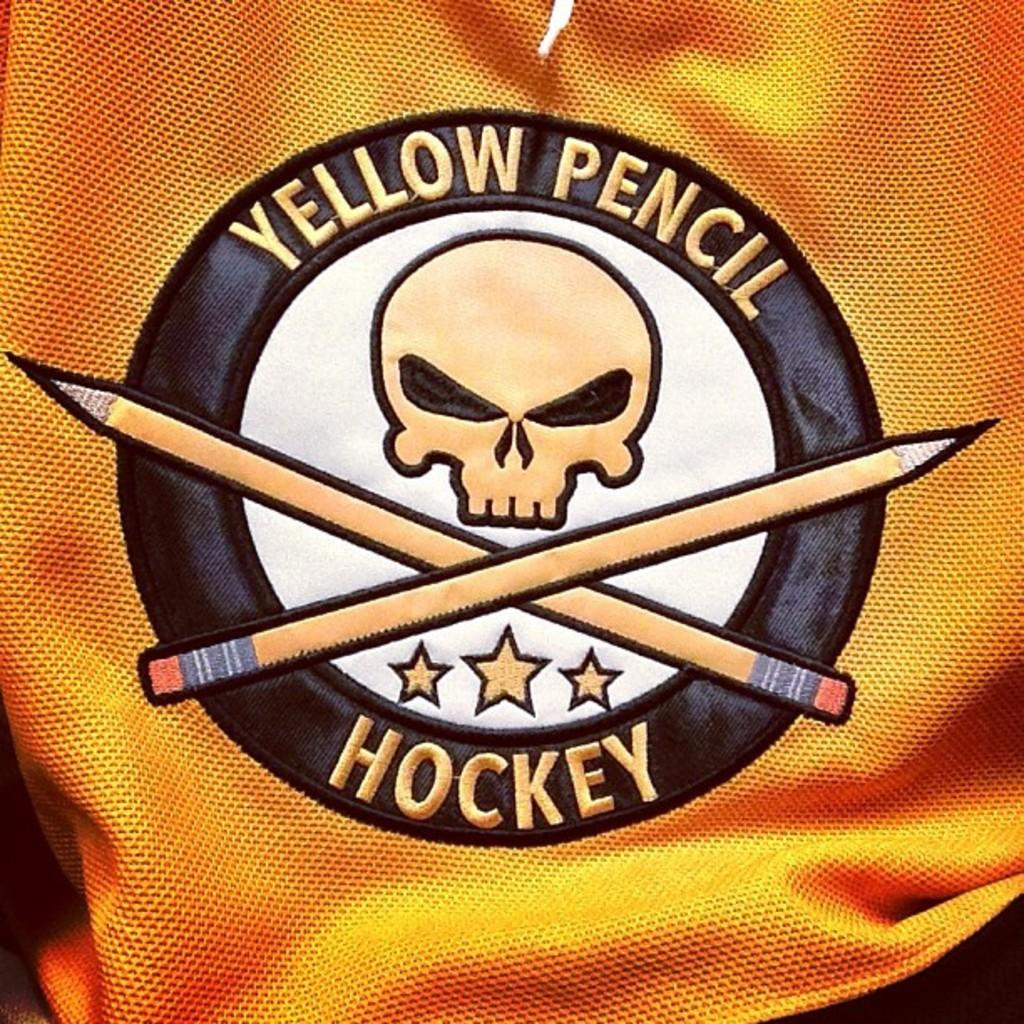What is depicted in the picture on the object? The facts provided do not specify what is depicted in the picture on the object. What color is the object? The object is yellow in color. What words are written on the object? The words "yellow pencil hockey" are written on the object. What type of wood can be seen in the background of the image? There is no wood or background visible in the image; it only features an object with a picture and words written on it. 